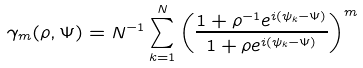<formula> <loc_0><loc_0><loc_500><loc_500>\gamma _ { m } ( \rho , \Psi ) = N ^ { - 1 } \sum _ { k = 1 } ^ { N } \left ( \frac { 1 + \rho ^ { - 1 } e ^ { i ( \psi _ { k } - \Psi ) } } { 1 + \rho e ^ { i ( \psi _ { k } - \Psi ) } } \right ) ^ { m }</formula> 